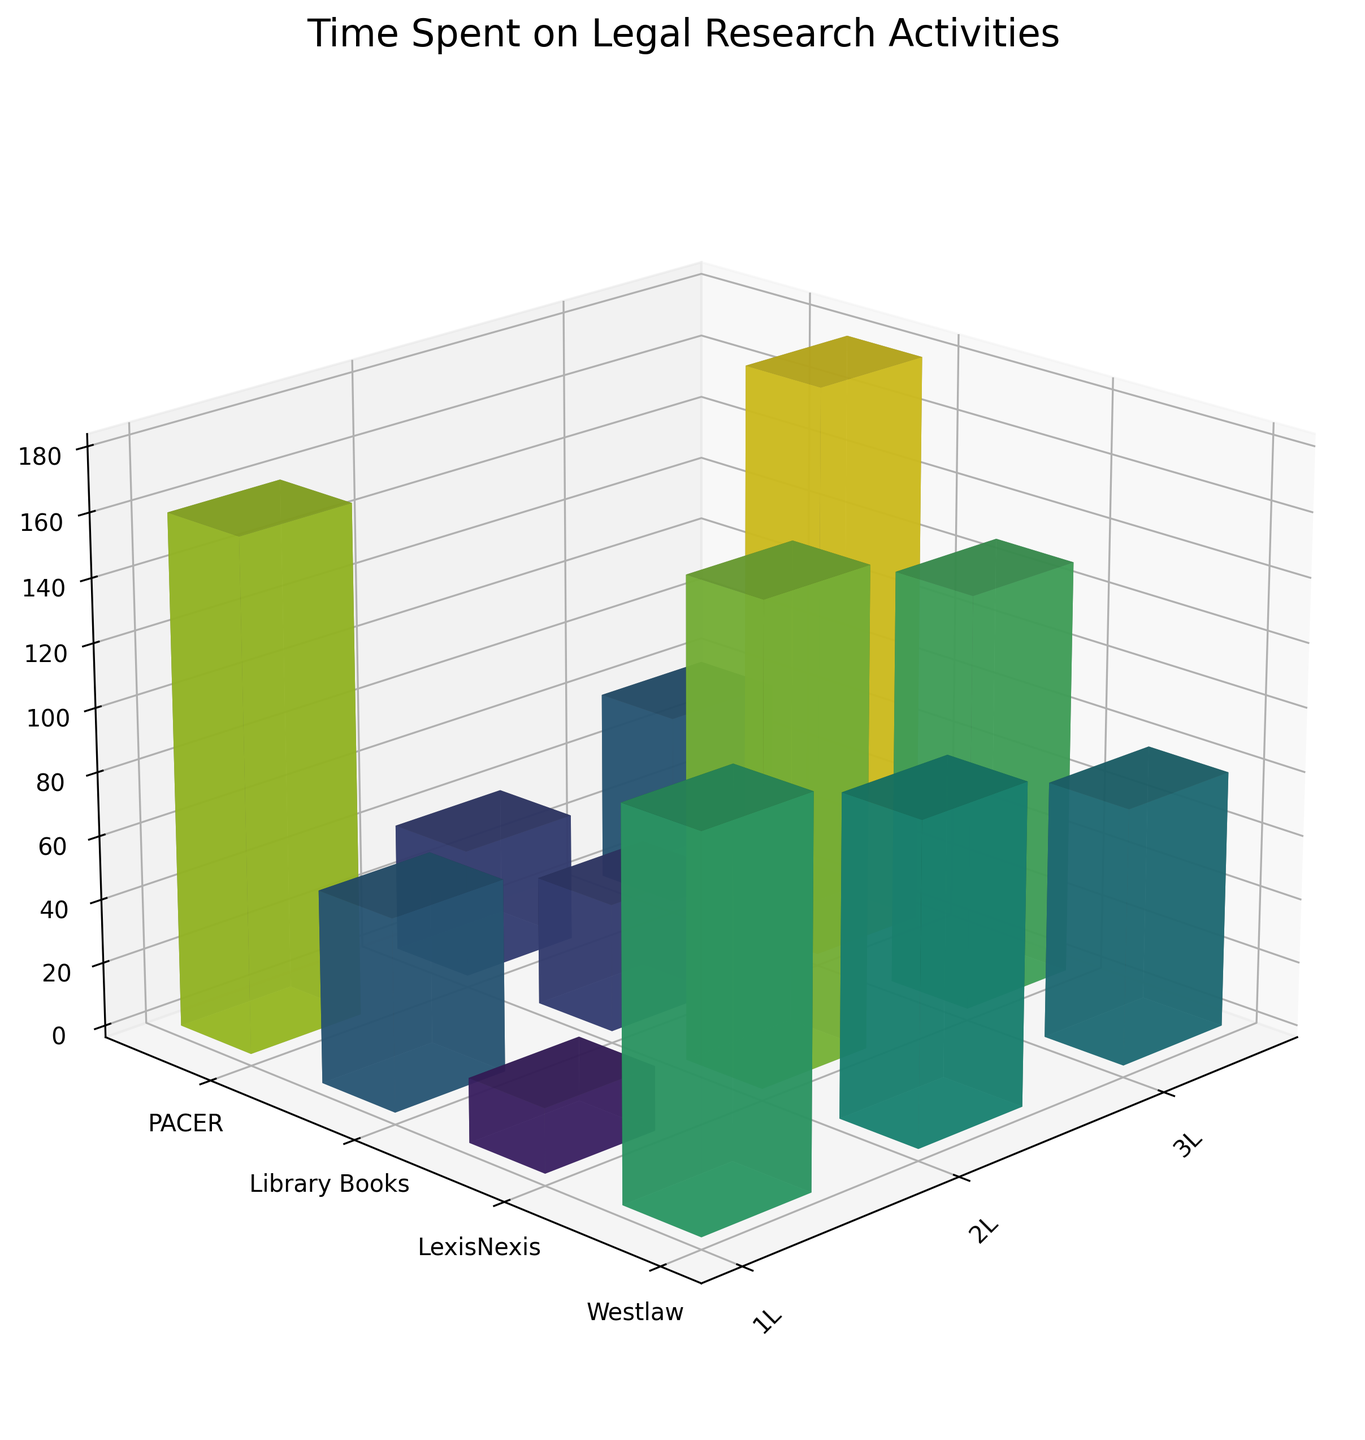what is the title of the plot? The title of the plot is typically found at the top of the figure. In this case, it can be seen as 'Time Spent on Legal Research Activities'.
Answer: Time Spent on Legal Research Activities How many hours did 1L students spend on PACER? Look at the bar corresponding to 1L students and PACER. The height of the bar indicates the hours spent, which is 20.
Answer: 20 What is the total time spent on LexisNexis by all academic years combined? Add the hours spent on LexisNexis by 1L, 2L, and 3L students: 100 + 130 + 160 = 390 hours.
Answer: 390 Which research method had the least amount of hours spent by 3L students? Compare the height of the bars for 3L students. The lowest bar corresponds to Library Books with 40 hours.
Answer: Library Books How many research methods are displayed on the y-axis? Count the number of unique ticks on the y-axis. There are four methods: Westlaw, LexisNexis, Library Books, and PACER.
Answer: 4 What is the average time spent on Westlaw across all academic years? Add the time spent on Westlaw by all academic years and divide by 3: (120 + 150 + 180) / 3 = 450 / 3 = 150 hours.
Answer: 150 Which academic year spent the most time on legal research activities overall? Sum up the hours for each academic year and compare: 
1L: 120 + 100 + 80 + 20 = 320 
2L: 150 + 130 + 60 + 40 = 380 
3L: 180 + 160 + 40 + 60 = 440 
The 3L year spent the most time.
Answer: 3L How does the time spent on Library Books compare between 2L and 3L students? Compare the heights of the bars for Library Books for 2L and 3L students. 
2L: 60 hours 
3L: 40 hours. 
2L students spent more time.
Answer: 2L students spent more time Which research method has the highest variance in time spent across academic years? Calculate the variance for each method:
Westlaw: var([120, 150, 180]) = 600
LexisNexis: var([100, 130, 160]) = 600
Library Books: var([80, 60, 40]) = 400
PACER: var([20, 40, 60]) = 400
Westlaw and LexisNexis both have the highest variance.
Answer: Westlaw and LexisNexis Between which academic years did the time spent on PACER increase? Compare the heights of the bars for PACER: 
1L to 2L: 20 to 40 (increased) 
2L to 3L: 40 to 60 (increased)
So, the time increased between both 1L to 2L and 2L to 3L.
Answer: 1L to 2L and 2L to 3L 